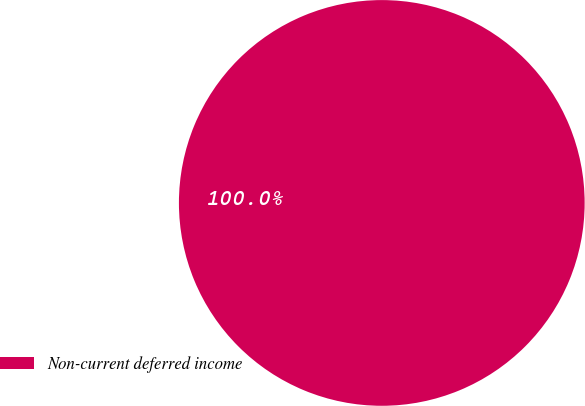<chart> <loc_0><loc_0><loc_500><loc_500><pie_chart><fcel>Non-current deferred income<nl><fcel>100.0%<nl></chart> 